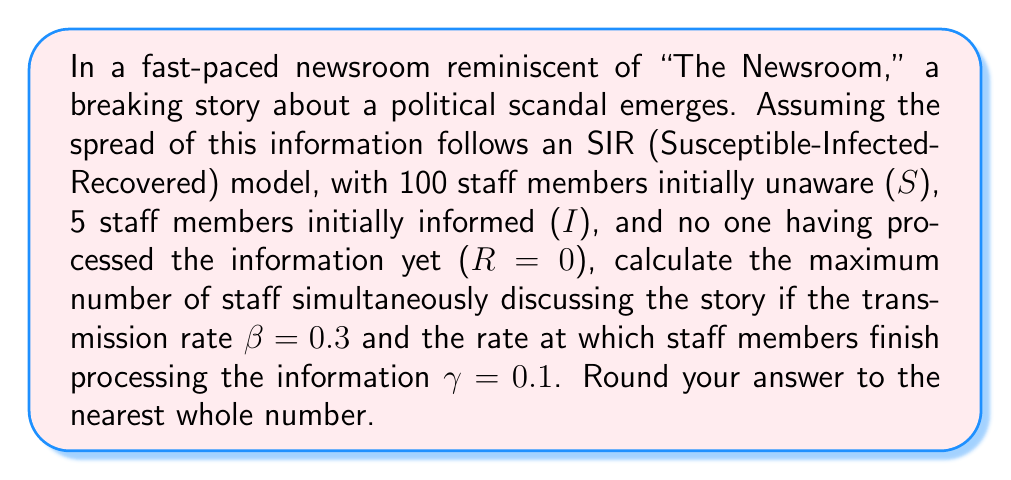Show me your answer to this math problem. To solve this problem, we'll use the SIR model adapted to information spread in a newsroom setting. Let's break it down step-by-step:

1) In the SIR model, the rate of change for the infected (in this case, informed) population is given by:

   $$\frac{dI}{dt} = \beta SI - \gamma I$$

2) The maximum number of infected (informed) individuals occurs when $\frac{dI}{dt} = 0$. At this point:

   $$\beta SI = \gamma I$$

3) We can rearrange this to:

   $$S = \frac{\gamma}{\beta}$$

4) This is known as the threshold value of S, often denoted as $S^*$.

5) Substituting the given values:

   $$S^* = \frac{0.1}{0.3} = \frac{1}{3}$$

6) Now, we can use the conservation of population in the SIR model:

   $$N = S + I + R$$

   Where N is the total population (105 in this case).

7) At the peak of infection (information spread), we have:

   $$105 = \frac{1}{3} + I + R$$

8) We also know that initially, S + I = 105 (as R starts at 0). As the infection spreads, S decreases and R increases, but their sum remains constant:

   $$S + R = 100$$

9) At the peak, S = $\frac{1}{3}$, so:

   $$R = 100 - \frac{1}{3} = \frac{299}{3}$$

10) Substituting this back into the equation from step 7:

    $$105 = \frac{1}{3} + I + \frac{299}{3}$$

11) Solving for I:

    $$I = 105 - \frac{1}{3} - \frac{299}{3} = \frac{316}{3} - \frac{300}{3} = \frac{16}{3} \approx 5.33$$

12) Rounding to the nearest whole number:

    $$I \approx 5$$
Answer: 5 staff members 